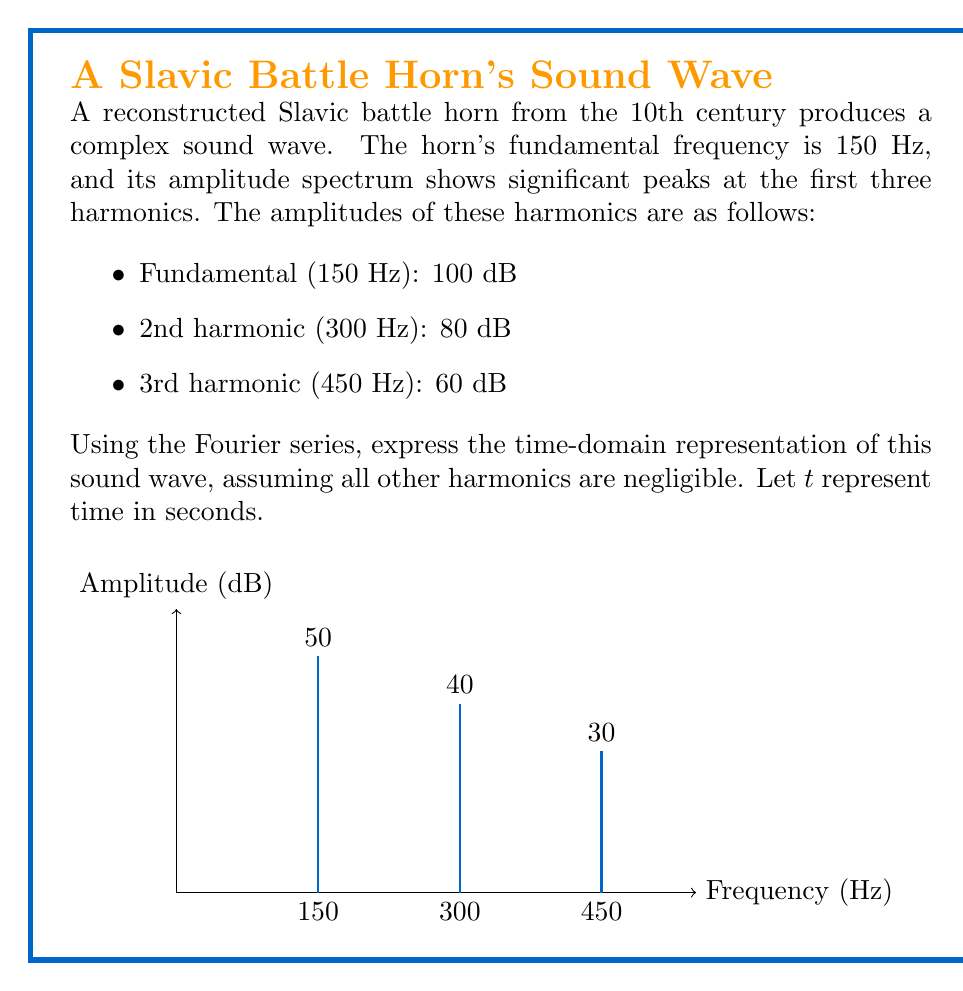Can you answer this question? To express the time-domain representation of the sound wave using the Fourier series, we need to follow these steps:

1) The general form of a Fourier series for a periodic function is:

   $$f(t) = A_0 + \sum_{n=1}^{\infty} [A_n \cos(n\omega_0 t) + B_n \sin(n\omega_0 t)]$$

   where $\omega_0 = 2\pi f_0$, and $f_0$ is the fundamental frequency.

2) In this case, we only have cosine terms (assuming the phase is 0 for simplicity), so our series will look like:

   $$f(t) = A_1 \cos(\omega_0 t) + A_2 \cos(2\omega_0 t) + A_3 \cos(3\omega_0 t)$$

3) We need to convert the amplitudes from dB to linear scale. The formula is:

   $$A = 10^{(dB/20)}$$

   For the fundamental: $A_1 = 10^{(100/20)} = 10^5 = 100000$
   For the 2nd harmonic: $A_2 = 10^{(80/20)} = 10^4 = 10000$
   For the 3rd harmonic: $A_3 = 10^{(60/20)} = 10^3 = 1000$

4) Now, we can write our Fourier series:

   $$f(t) = 100000 \cos(2\pi \cdot 150t) + 10000 \cos(2\pi \cdot 300t) + 1000 \cos(2\pi \cdot 450t)$$

5) Simplifying:

   $$f(t) = 100000 \cos(300\pi t) + 10000 \cos(600\pi t) + 1000 \cos(900\pi t)$$

This is the time-domain representation of the Slavic battle horn's sound wave.
Answer: $$f(t) = 100000 \cos(300\pi t) + 10000 \cos(600\pi t) + 1000 \cos(900\pi t)$$ 